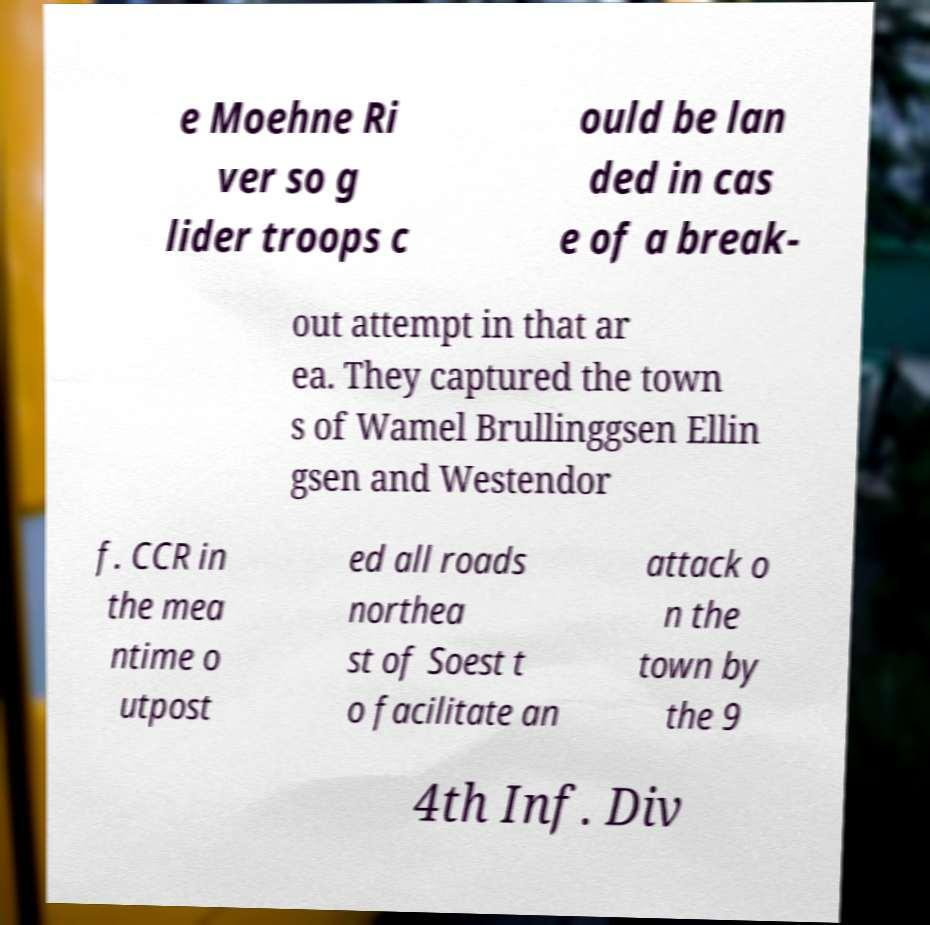Please identify and transcribe the text found in this image. e Moehne Ri ver so g lider troops c ould be lan ded in cas e of a break- out attempt in that ar ea. They captured the town s of Wamel Brullinggsen Ellin gsen and Westendor f. CCR in the mea ntime o utpost ed all roads northea st of Soest t o facilitate an attack o n the town by the 9 4th Inf. Div 